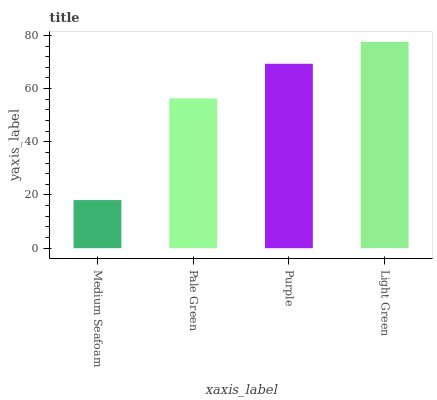Is Pale Green the minimum?
Answer yes or no. No. Is Pale Green the maximum?
Answer yes or no. No. Is Pale Green greater than Medium Seafoam?
Answer yes or no. Yes. Is Medium Seafoam less than Pale Green?
Answer yes or no. Yes. Is Medium Seafoam greater than Pale Green?
Answer yes or no. No. Is Pale Green less than Medium Seafoam?
Answer yes or no. No. Is Purple the high median?
Answer yes or no. Yes. Is Pale Green the low median?
Answer yes or no. Yes. Is Pale Green the high median?
Answer yes or no. No. Is Purple the low median?
Answer yes or no. No. 